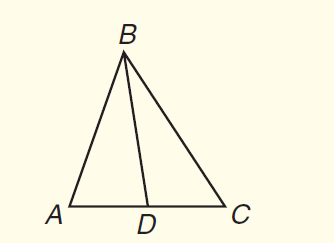Answer the mathemtical geometry problem and directly provide the correct option letter.
Question: In \triangle A B C, B D is a median. If A D = 3 x + 5 and C D = 5 x - 1, find A C.
Choices: A: 3 B: 11 C: 14 D: 28 D 